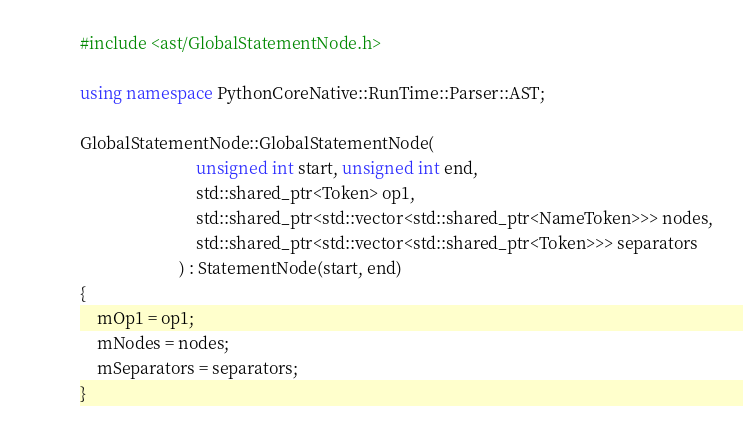<code> <loc_0><loc_0><loc_500><loc_500><_C++_>
#include <ast/GlobalStatementNode.h>

using namespace PythonCoreNative::RunTime::Parser::AST;

GlobalStatementNode::GlobalStatementNode(  
                            unsigned int start, unsigned int end, 
                            std::shared_ptr<Token> op1,
                            std::shared_ptr<std::vector<std::shared_ptr<NameToken>>> nodes,
                            std::shared_ptr<std::vector<std::shared_ptr<Token>>> separators
                        ) : StatementNode(start, end)
{
    mOp1 = op1;
    mNodes = nodes;
    mSeparators = separators;
}
</code> 